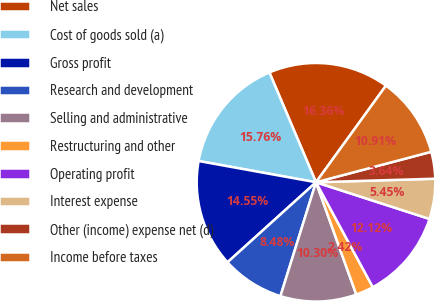Convert chart to OTSL. <chart><loc_0><loc_0><loc_500><loc_500><pie_chart><fcel>Net sales<fcel>Cost of goods sold (a)<fcel>Gross profit<fcel>Research and development<fcel>Selling and administrative<fcel>Restructuring and other<fcel>Operating profit<fcel>Interest expense<fcel>Other (income) expense net (d)<fcel>Income before taxes<nl><fcel>16.36%<fcel>15.76%<fcel>14.55%<fcel>8.48%<fcel>10.3%<fcel>2.42%<fcel>12.12%<fcel>5.45%<fcel>3.64%<fcel>10.91%<nl></chart> 